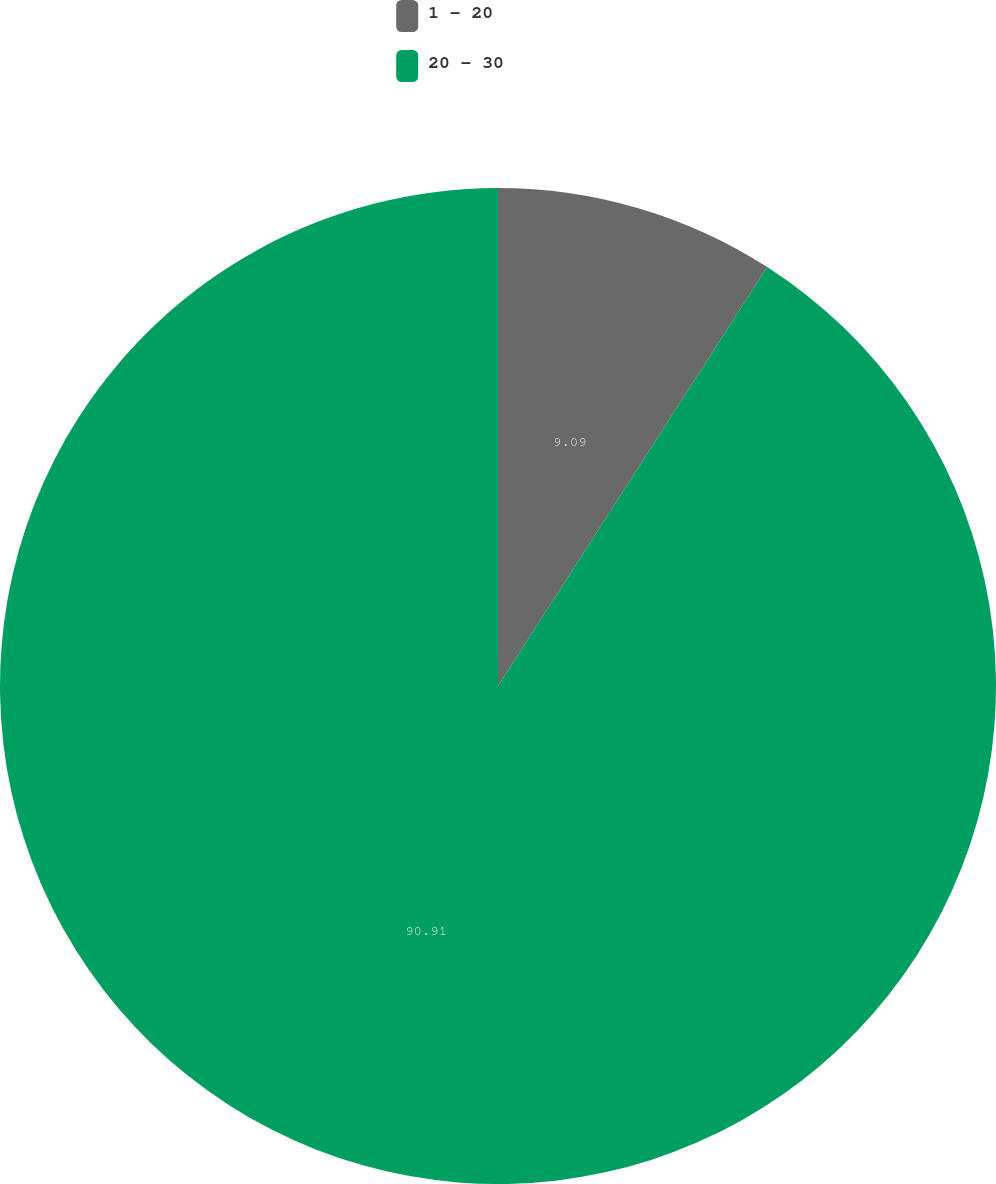Convert chart to OTSL. <chart><loc_0><loc_0><loc_500><loc_500><pie_chart><fcel>1 - 20<fcel>20 - 30<nl><fcel>9.09%<fcel>90.91%<nl></chart> 